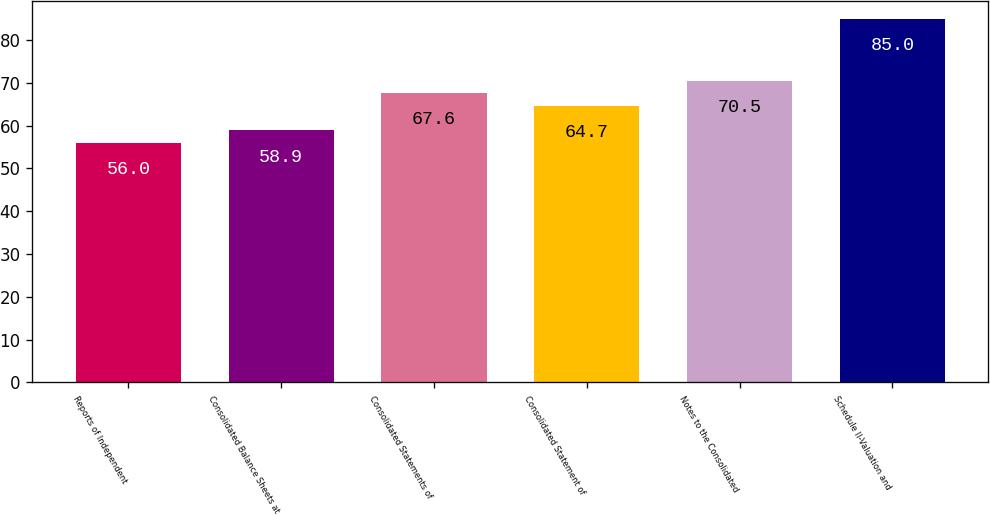Convert chart to OTSL. <chart><loc_0><loc_0><loc_500><loc_500><bar_chart><fcel>Reports of Independent<fcel>Consolidated Balance Sheets at<fcel>Consolidated Statements of<fcel>Consolidated Statement of<fcel>Notes to the Consolidated<fcel>Schedule II-Valuation and<nl><fcel>56<fcel>58.9<fcel>67.6<fcel>64.7<fcel>70.5<fcel>85<nl></chart> 